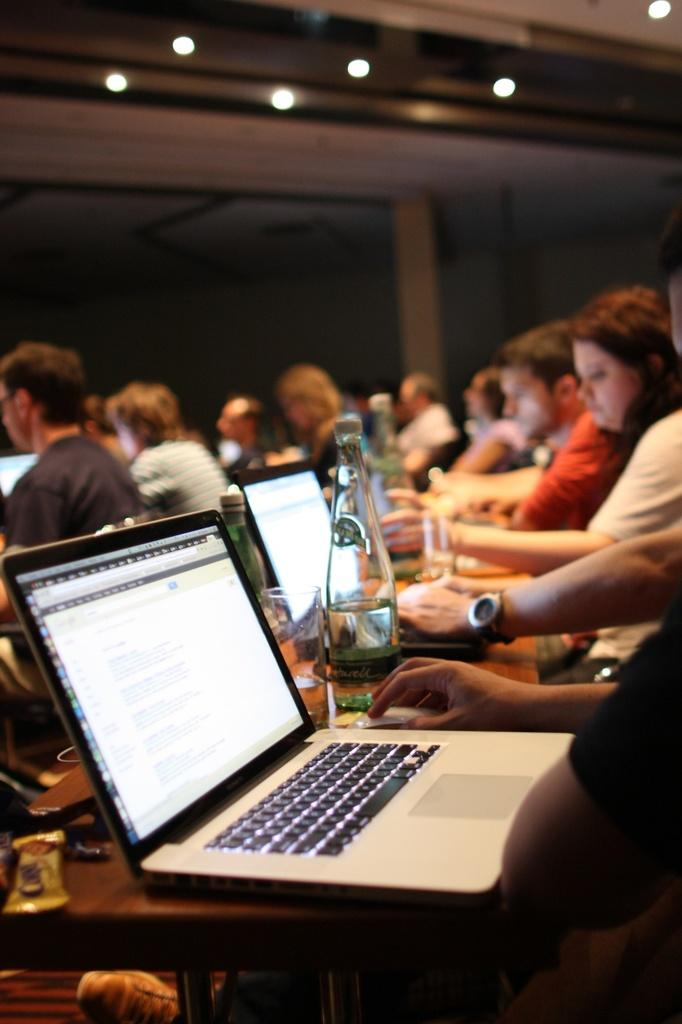What electronic device is on the table in the image? There is a silver laptop on the table. What are the people in the image doing with the laptop? The people are sitting and working on the laptop. What part of the room can be seen in the image? The ceiling is visible in the image. What type of lighting is present on the ceiling? There are spotlights on the ceiling. What advice can be seen written on the laptop screen in the image? There is no advice visible on the laptop screen in the image. 